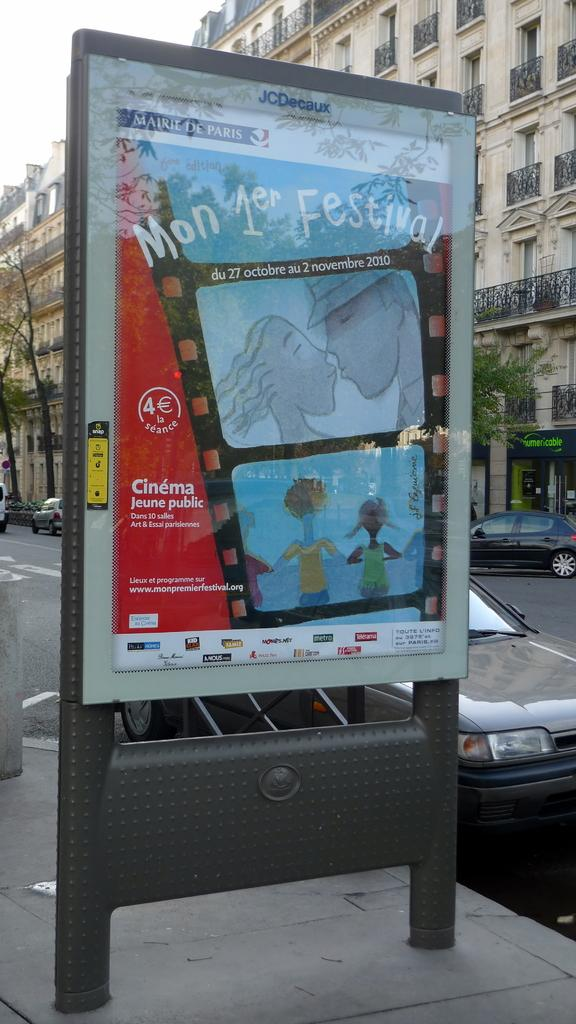<image>
Provide a brief description of the given image. An outdoor cinema sign reads "Mon 1er Festival." 